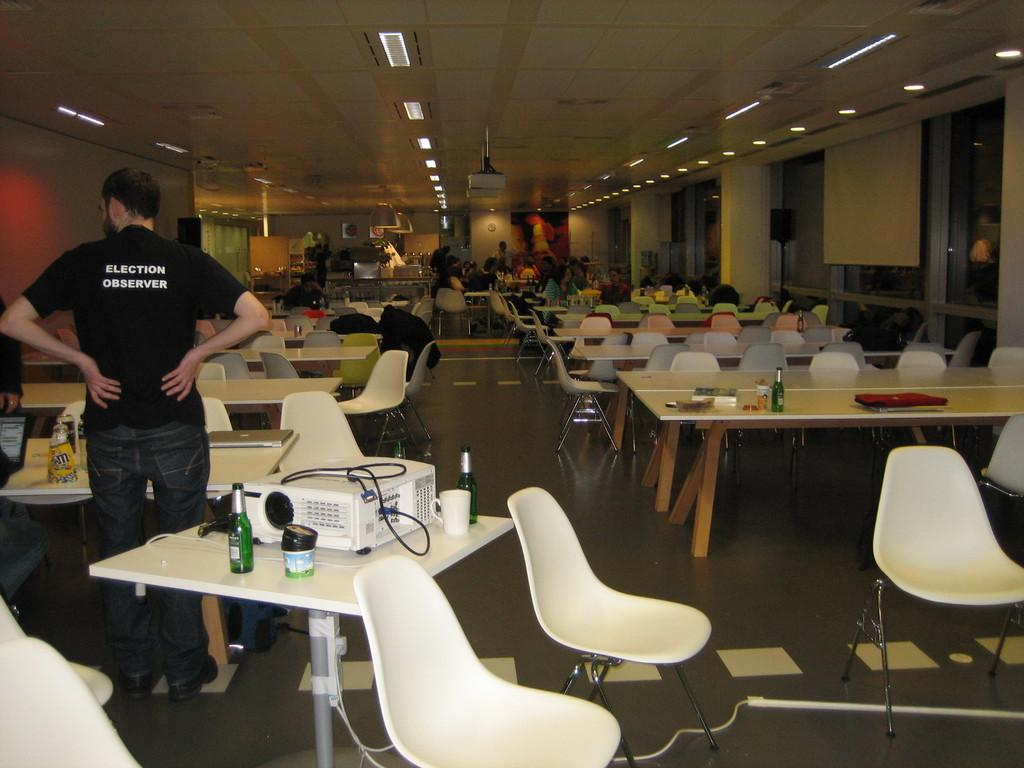What is the main object on the table in the image? There is a projector on a table in the image. Who is present near the projector? A person is standing beside the projector. What might be the purpose of the empty tables and chairs in front of the person? The empty tables and chairs suggest that a presentation or event is about to take place. How many lip butter products are visible on the table? There are no lip butter products visible on the table in the image. Can you count the number of ladybugs crawling on the projector? There are no ladybugs present on the projector or in the image. 